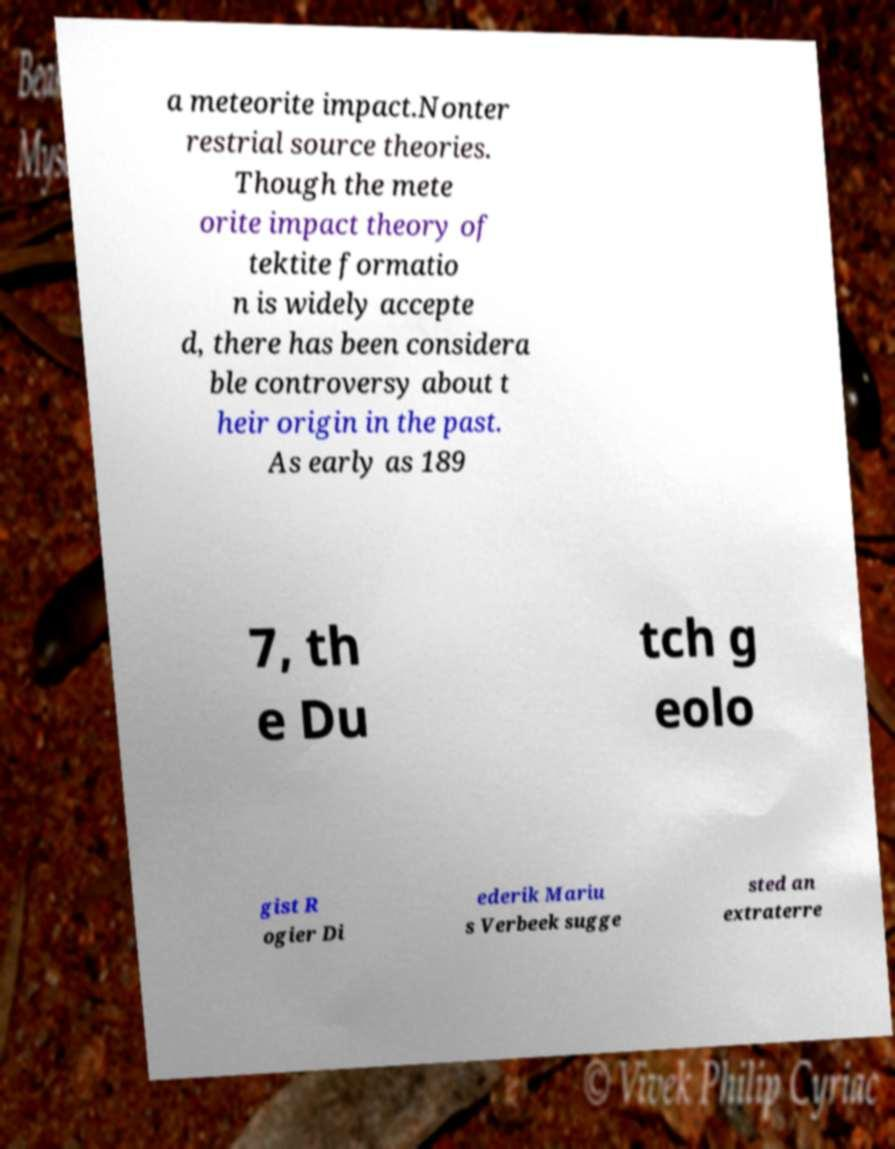Please identify and transcribe the text found in this image. a meteorite impact.Nonter restrial source theories. Though the mete orite impact theory of tektite formatio n is widely accepte d, there has been considera ble controversy about t heir origin in the past. As early as 189 7, th e Du tch g eolo gist R ogier Di ederik Mariu s Verbeek sugge sted an extraterre 